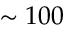Convert formula to latex. <formula><loc_0><loc_0><loc_500><loc_500>\sim 1 0 0</formula> 